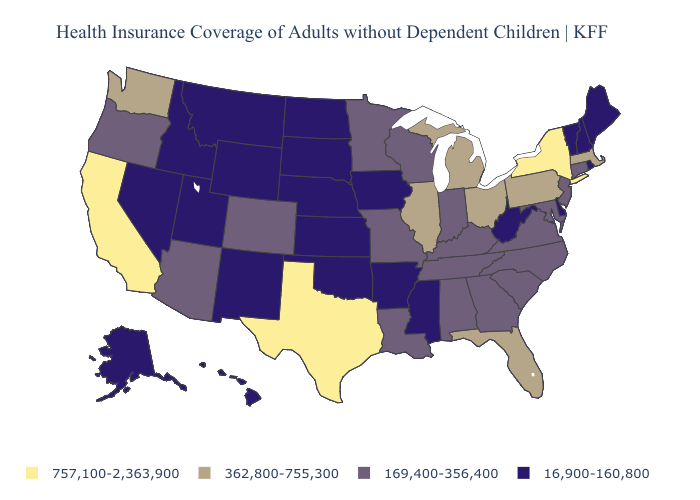What is the highest value in the West ?
Concise answer only. 757,100-2,363,900. Which states have the highest value in the USA?
Short answer required. California, New York, Texas. Name the states that have a value in the range 169,400-356,400?
Keep it brief. Alabama, Arizona, Colorado, Connecticut, Georgia, Indiana, Kentucky, Louisiana, Maryland, Minnesota, Missouri, New Jersey, North Carolina, Oregon, South Carolina, Tennessee, Virginia, Wisconsin. How many symbols are there in the legend?
Write a very short answer. 4. What is the highest value in states that border South Dakota?
Concise answer only. 169,400-356,400. What is the value of Tennessee?
Keep it brief. 169,400-356,400. Which states have the highest value in the USA?
Give a very brief answer. California, New York, Texas. Name the states that have a value in the range 757,100-2,363,900?
Short answer required. California, New York, Texas. What is the value of Missouri?
Give a very brief answer. 169,400-356,400. What is the value of Arizona?
Answer briefly. 169,400-356,400. Name the states that have a value in the range 16,900-160,800?
Quick response, please. Alaska, Arkansas, Delaware, Hawaii, Idaho, Iowa, Kansas, Maine, Mississippi, Montana, Nebraska, Nevada, New Hampshire, New Mexico, North Dakota, Oklahoma, Rhode Island, South Dakota, Utah, Vermont, West Virginia, Wyoming. What is the value of Utah?
Answer briefly. 16,900-160,800. Does Texas have the highest value in the USA?
Write a very short answer. Yes. Among the states that border Arizona , which have the highest value?
Be succinct. California. Name the states that have a value in the range 16,900-160,800?
Short answer required. Alaska, Arkansas, Delaware, Hawaii, Idaho, Iowa, Kansas, Maine, Mississippi, Montana, Nebraska, Nevada, New Hampshire, New Mexico, North Dakota, Oklahoma, Rhode Island, South Dakota, Utah, Vermont, West Virginia, Wyoming. 